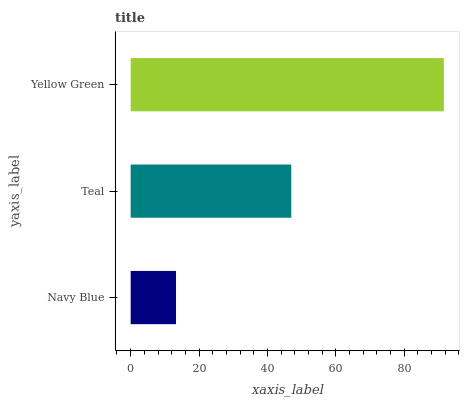Is Navy Blue the minimum?
Answer yes or no. Yes. Is Yellow Green the maximum?
Answer yes or no. Yes. Is Teal the minimum?
Answer yes or no. No. Is Teal the maximum?
Answer yes or no. No. Is Teal greater than Navy Blue?
Answer yes or no. Yes. Is Navy Blue less than Teal?
Answer yes or no. Yes. Is Navy Blue greater than Teal?
Answer yes or no. No. Is Teal less than Navy Blue?
Answer yes or no. No. Is Teal the high median?
Answer yes or no. Yes. Is Teal the low median?
Answer yes or no. Yes. Is Navy Blue the high median?
Answer yes or no. No. Is Navy Blue the low median?
Answer yes or no. No. 